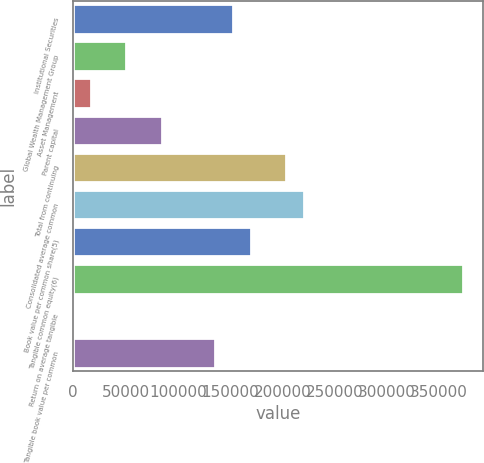Convert chart. <chart><loc_0><loc_0><loc_500><loc_500><bar_chart><fcel>Institutional Securities<fcel>Global Wealth Management Group<fcel>Asset Management<fcel>Parent capital<fcel>Total from continuing<fcel>Consolidated average common<fcel>Book value per common share(5)<fcel>Tangible common equity(6)<fcel>Return on average tangible<fcel>Tangible book value per common<nl><fcel>152614<fcel>50871.4<fcel>16957.2<fcel>84785.6<fcel>203485<fcel>220442<fcel>169571<fcel>373056<fcel>0.1<fcel>135657<nl></chart> 